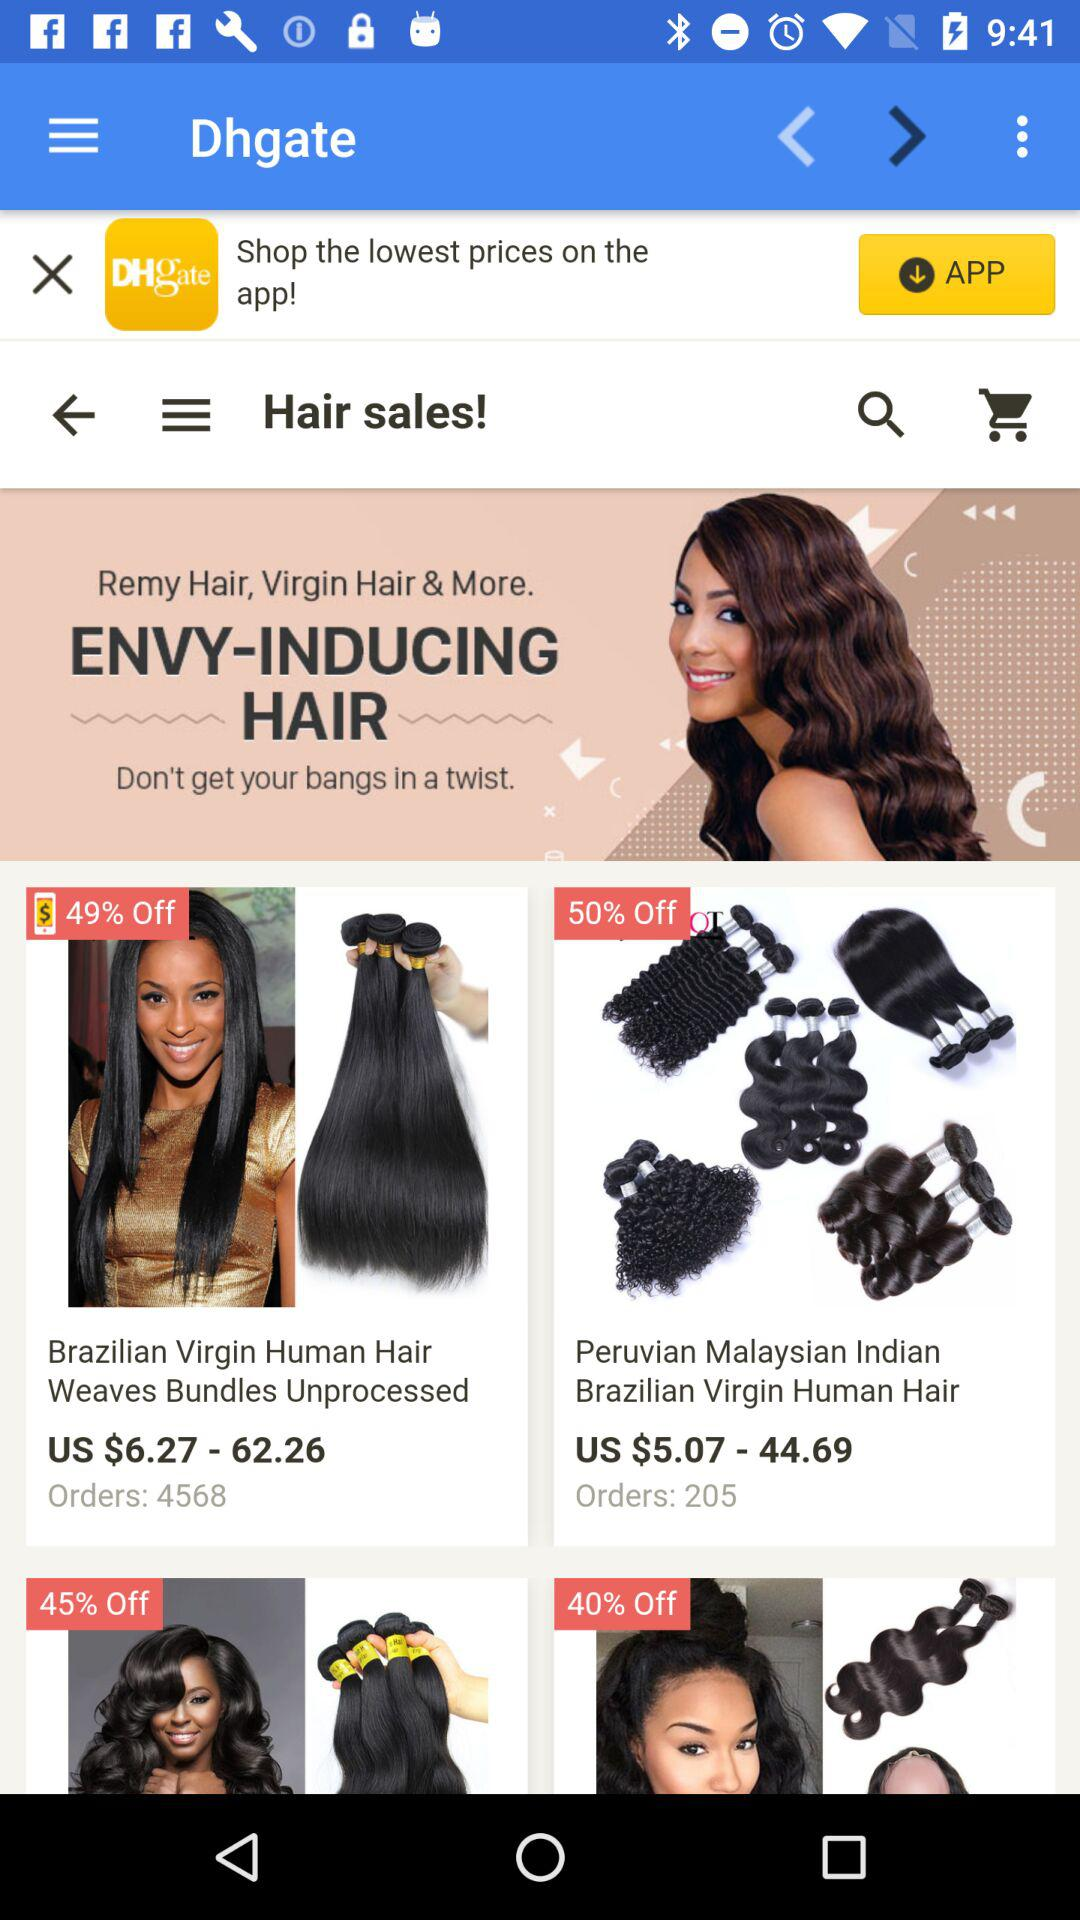Which item has a higher discount, the first or the second?
Answer the question using a single word or phrase. Second 